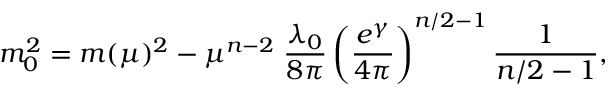Convert formula to latex. <formula><loc_0><loc_0><loc_500><loc_500>m _ { 0 } ^ { 2 } = m ( \mu ) ^ { 2 } - \mu ^ { n - 2 } \, \frac { \lambda _ { 0 } } { 8 \pi } \left ( \frac { e ^ { \gamma } } { 4 \pi } \right ) ^ { n / 2 - 1 } \frac { 1 } { n / 2 - 1 } ,</formula> 